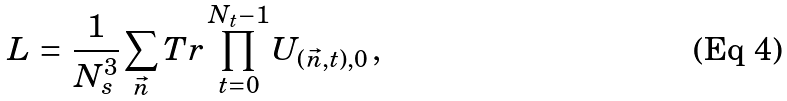Convert formula to latex. <formula><loc_0><loc_0><loc_500><loc_500>L \, = \, \frac { 1 } { N ^ { 3 } _ { s } } \sum _ { \vec { n } } T r \prod ^ { N _ { t } - 1 } _ { t = 0 } U _ { ( \vec { n } , t ) , 0 } \, ,</formula> 